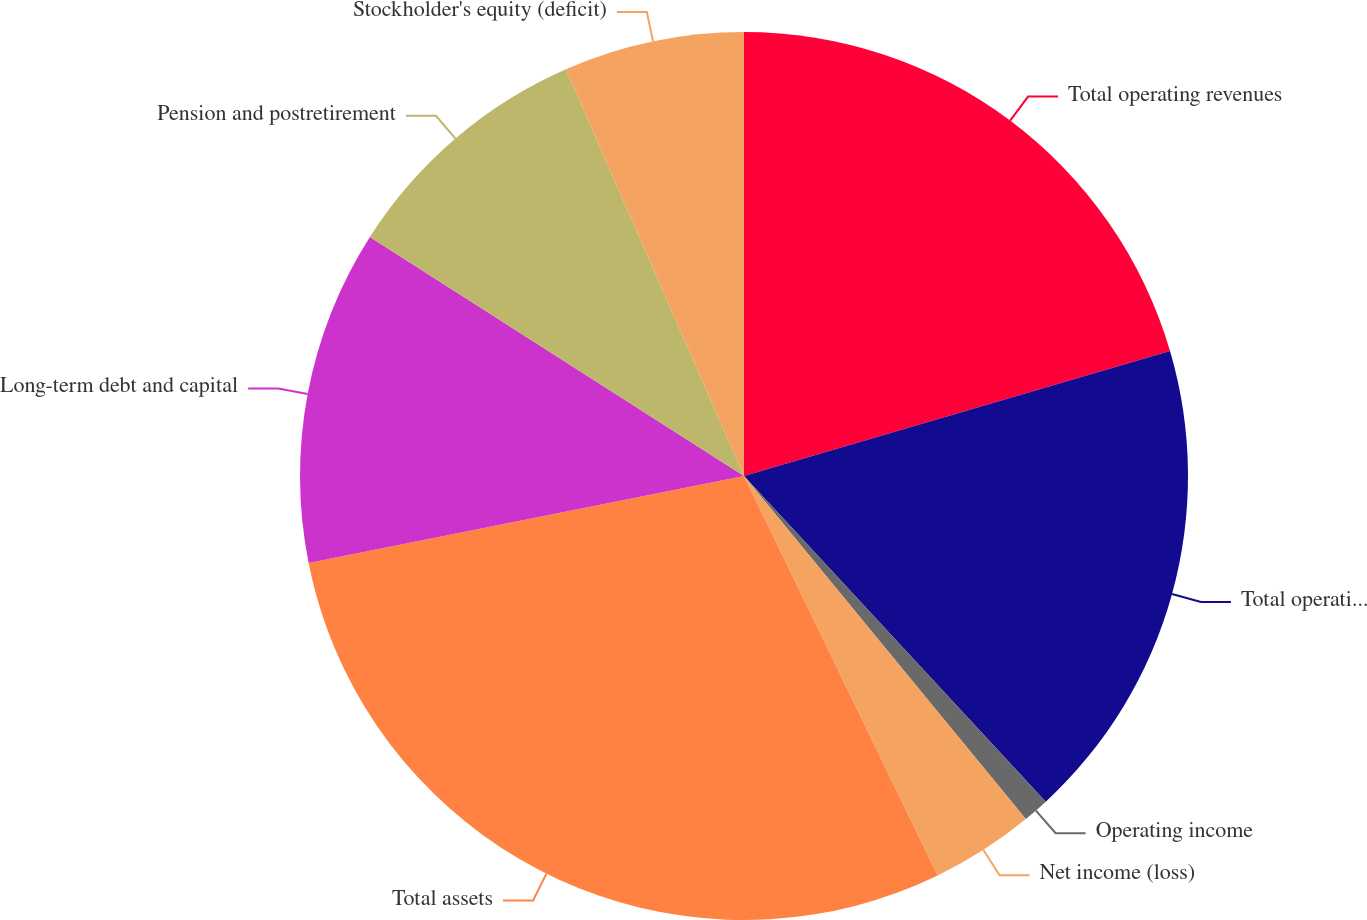Convert chart to OTSL. <chart><loc_0><loc_0><loc_500><loc_500><pie_chart><fcel>Total operating revenues<fcel>Total operating expenses<fcel>Operating income<fcel>Net income (loss)<fcel>Total assets<fcel>Long-term debt and capital<fcel>Pension and postretirement<fcel>Stockholder's equity (deficit)<nl><fcel>20.46%<fcel>17.65%<fcel>0.95%<fcel>3.76%<fcel>29.05%<fcel>12.19%<fcel>9.38%<fcel>6.57%<nl></chart> 